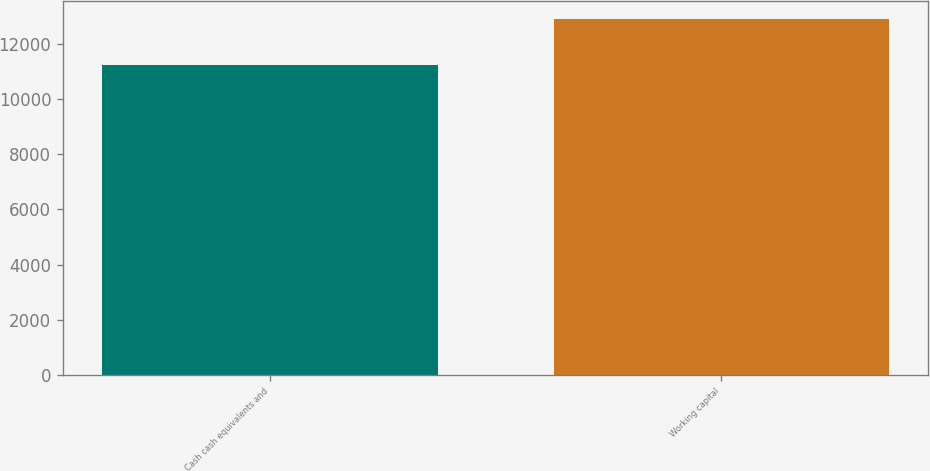Convert chart to OTSL. <chart><loc_0><loc_0><loc_500><loc_500><bar_chart><fcel>Cash cash equivalents and<fcel>Working capital<nl><fcel>11227<fcel>12896<nl></chart> 